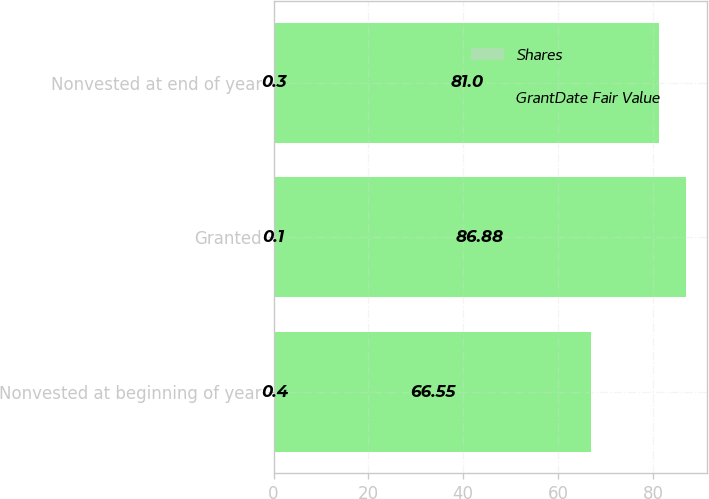Convert chart to OTSL. <chart><loc_0><loc_0><loc_500><loc_500><stacked_bar_chart><ecel><fcel>Nonvested at beginning of year<fcel>Granted<fcel>Nonvested at end of year<nl><fcel>Shares<fcel>0.4<fcel>0.1<fcel>0.3<nl><fcel>GrantDate Fair Value<fcel>66.55<fcel>86.88<fcel>81<nl></chart> 